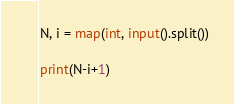<code> <loc_0><loc_0><loc_500><loc_500><_Python_>N, i = map(int, input().split())

print(N-i+1)
</code> 